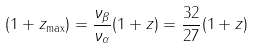Convert formula to latex. <formula><loc_0><loc_0><loc_500><loc_500>( 1 + z _ { \max } ) = \frac { \nu _ { \beta } } { \nu _ { \alpha } } ( 1 + z ) = \frac { 3 2 } { 2 7 } ( 1 + z )</formula> 